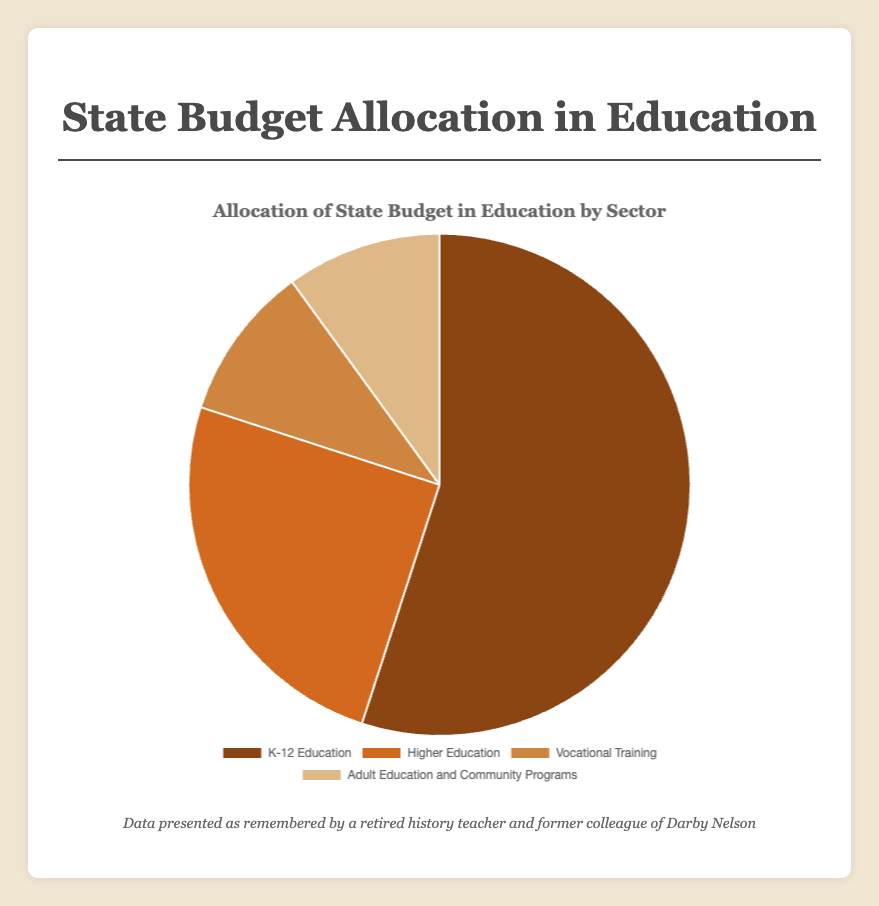Which sector receives the largest share of the state budget allocation in education? The pie chart indicates that K-12 Education receives 55% of the state budget allocation, which is the largest share among all sectors.
Answer: K-12 Education Which two sectors have an equal percentage share of the state budget allocation? The data shows that Vocational Training and Adult Education and Community Programs each receive 10% of the budget.
Answer: Vocational Training and Adult Education and Community Programs What is the combined budget allocation percentage for Vocational Training and Higher Education? The chart indicates Vocational Training receives 10% and Higher Education receives 25%. Combined, their percentage is 10% + 25% = 35%.
Answer: 35% By how much does the budget allocation for K-12 Education exceed that of Higher Education? The pie chart shows K-12 Education at 55% and Higher Education at 25%. The difference is 55% - 25% = 30%.
Answer: 30% Which sector, if any, has a higher budget allocation than Adult Education and Community Programs but less than K-12 Education? The sectors available are K-12 Education, Higher Education, Vocational Training, and Adult Education and Community Programs. Higher Education receives 25%, which is more than Adult Education and Community Programs (10%) but less than K-12 Education (55%).
Answer: Higher Education What fraction of the state budget is allocated to Adult Education and Community Programs compared to the entire education budget? Adult Education and Community Programs receive 10%. To express this as a fraction, it is 10/100 or 1/10.
Answer: 1/10 If the budget for Vocational Training were doubled, what would its new percentage share be from the total budget? The current budget for Vocational Training is 10%. Doubling it makes it 10% * 2 = 20%.
Answer: 20% What is the total percentage of the budget allocation for sectors other than K-12 Education? The budget allocations for Higher Education, Vocational Training, and Adult Education and Community Programs are 25%, 10%, and 10%, respectively. Summing them gives us 25% + 10% + 10% = 45%.
Answer: 45% 